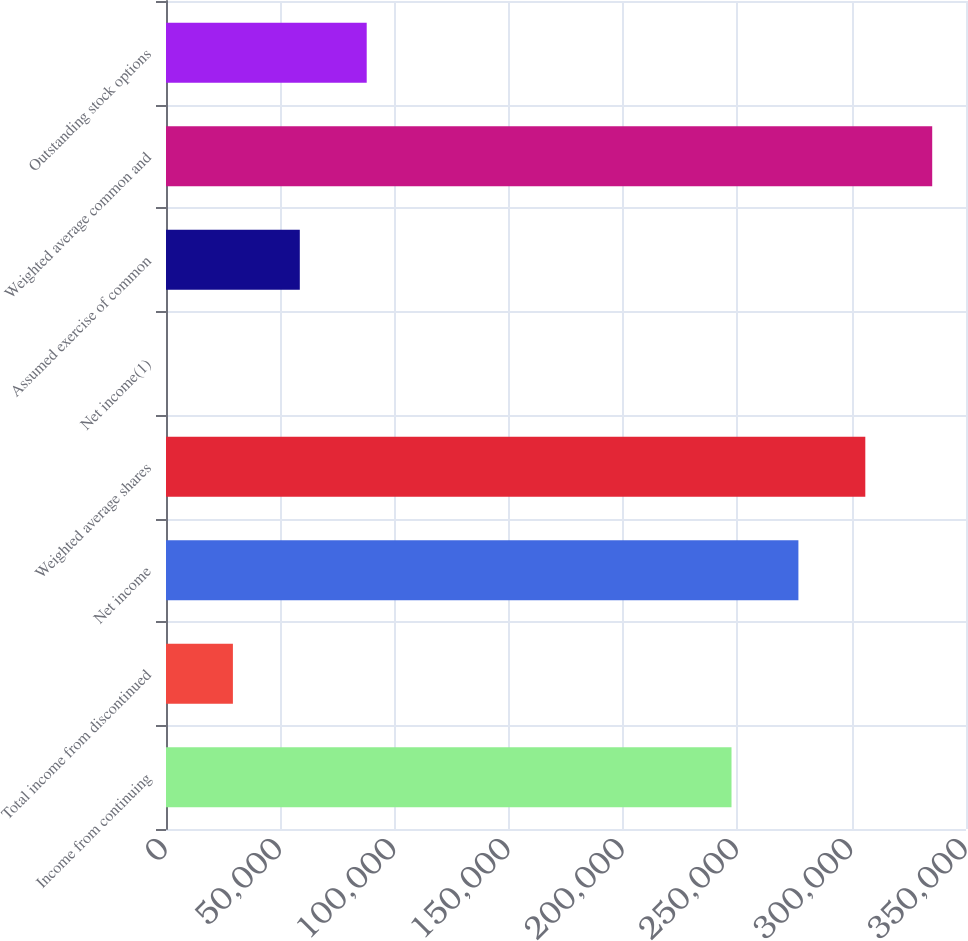Convert chart to OTSL. <chart><loc_0><loc_0><loc_500><loc_500><bar_chart><fcel>Income from continuing<fcel>Total income from discontinued<fcel>Net income<fcel>Weighted average shares<fcel>Net income(1)<fcel>Assumed exercise of common<fcel>Weighted average common and<fcel>Outstanding stock options<nl><fcel>247408<fcel>29270.6<fcel>276678<fcel>305947<fcel>0.85<fcel>58540.3<fcel>335217<fcel>87810<nl></chart> 